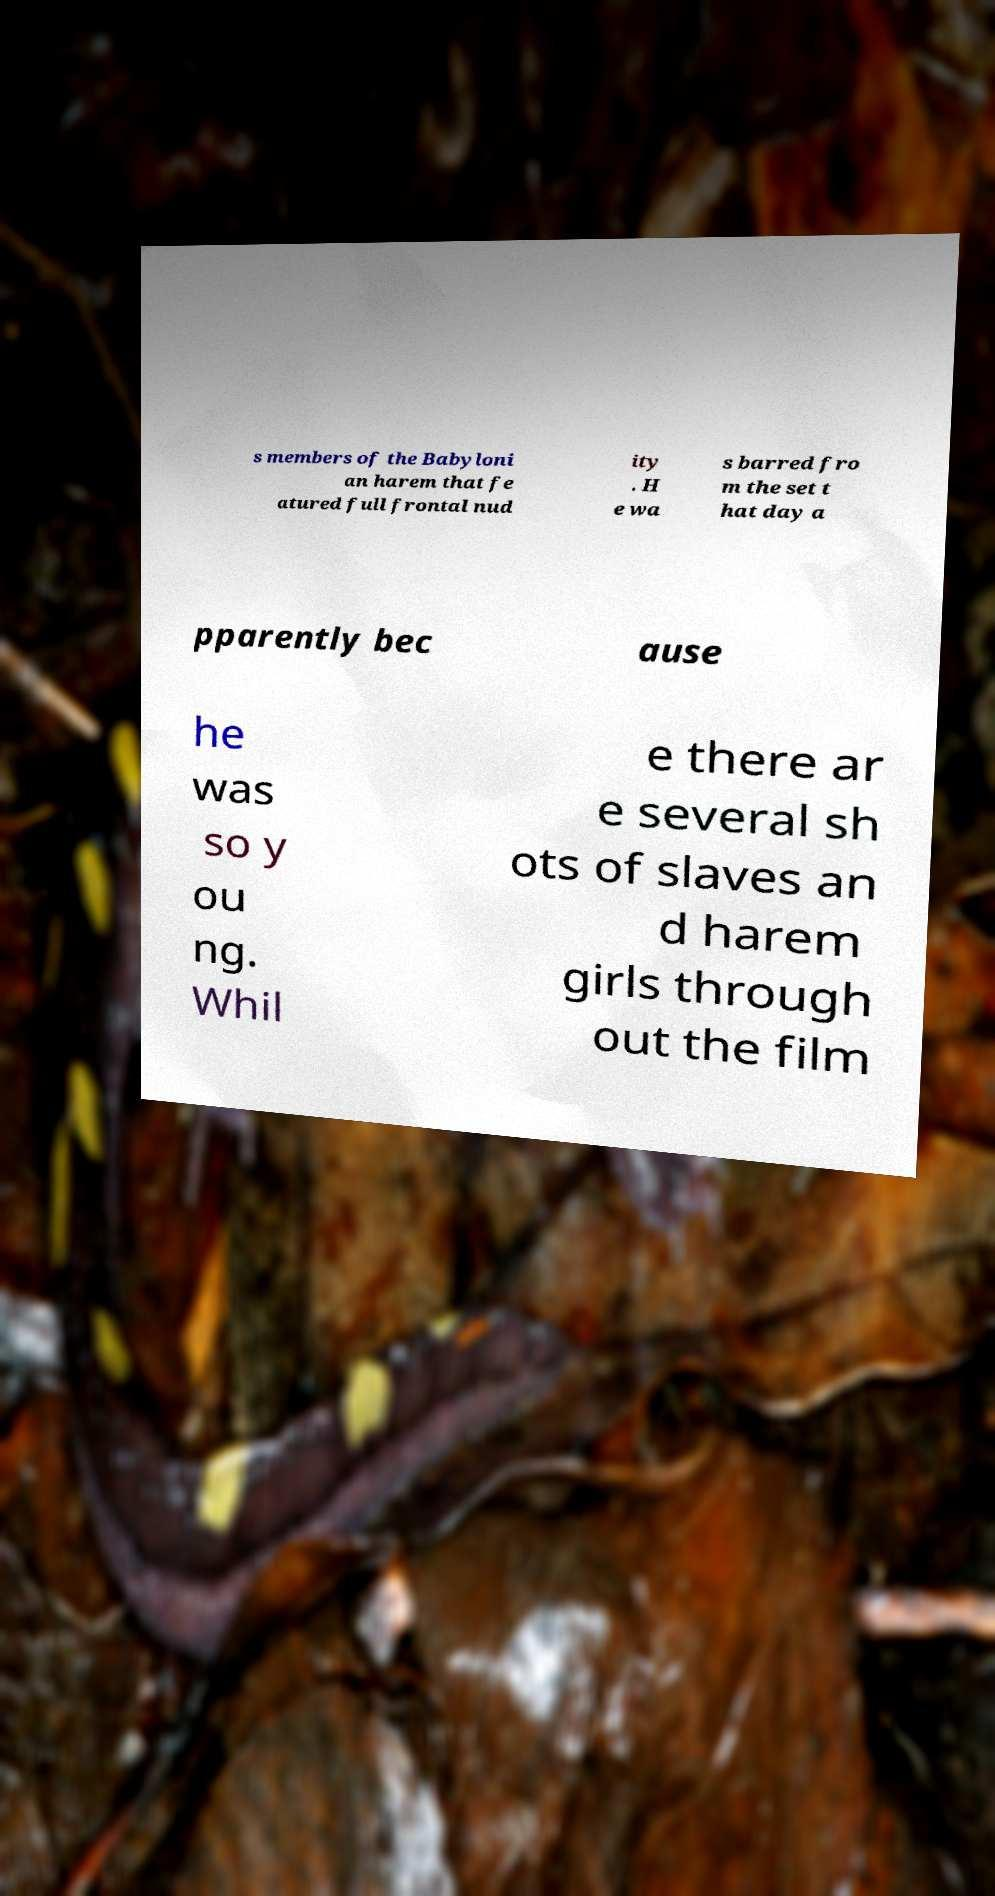There's text embedded in this image that I need extracted. Can you transcribe it verbatim? s members of the Babyloni an harem that fe atured full frontal nud ity . H e wa s barred fro m the set t hat day a pparently bec ause he was so y ou ng. Whil e there ar e several sh ots of slaves an d harem girls through out the film 